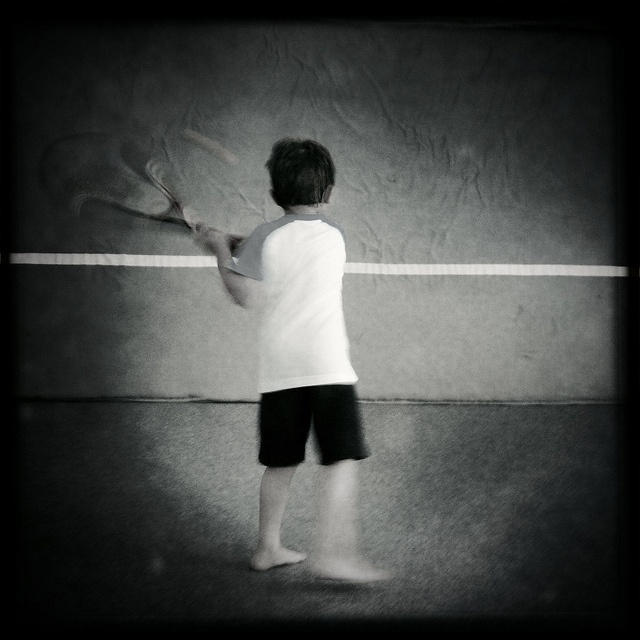Describe the objects in this image and their specific colors. I can see people in black, lightgray, darkgray, and gray tones, tennis racket in black and gray tones, and sports ball in black and gray tones in this image. 